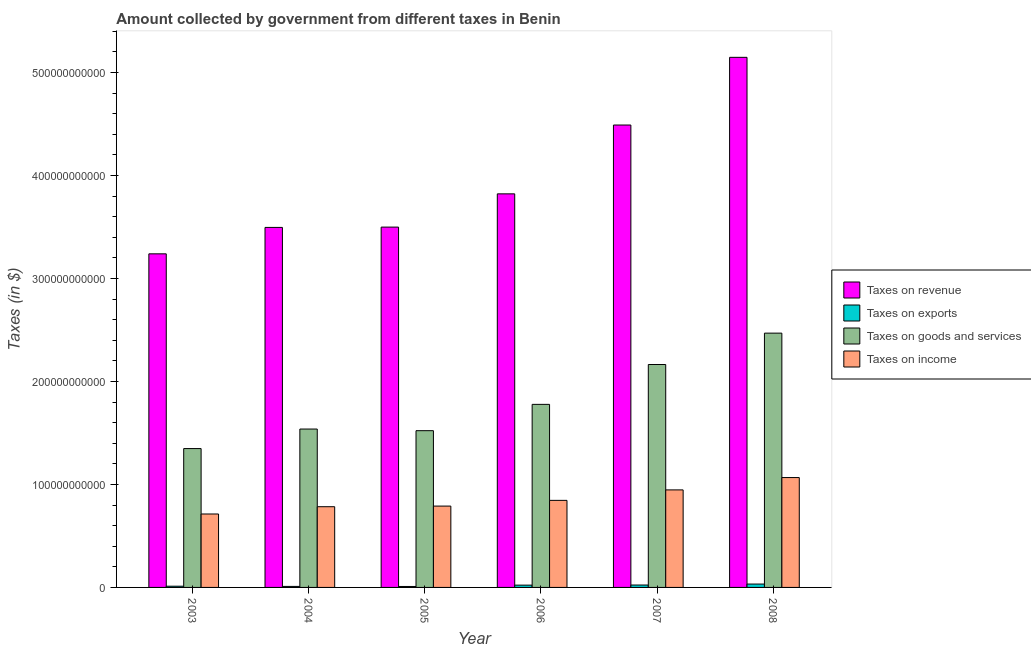Are the number of bars per tick equal to the number of legend labels?
Offer a terse response. Yes. Are the number of bars on each tick of the X-axis equal?
Keep it short and to the point. Yes. In how many cases, is the number of bars for a given year not equal to the number of legend labels?
Offer a very short reply. 0. What is the amount collected as tax on goods in 2008?
Your answer should be very brief. 2.47e+11. Across all years, what is the maximum amount collected as tax on revenue?
Provide a short and direct response. 5.15e+11. Across all years, what is the minimum amount collected as tax on goods?
Offer a very short reply. 1.35e+11. In which year was the amount collected as tax on revenue maximum?
Provide a succinct answer. 2008. In which year was the amount collected as tax on exports minimum?
Offer a terse response. 2005. What is the total amount collected as tax on revenue in the graph?
Give a very brief answer. 2.37e+12. What is the difference between the amount collected as tax on exports in 2007 and that in 2008?
Your answer should be compact. -9.29e+08. What is the difference between the amount collected as tax on revenue in 2005 and the amount collected as tax on goods in 2004?
Offer a terse response. 3.07e+08. What is the average amount collected as tax on goods per year?
Your answer should be very brief. 1.80e+11. In the year 2005, what is the difference between the amount collected as tax on exports and amount collected as tax on revenue?
Offer a terse response. 0. What is the ratio of the amount collected as tax on income in 2005 to that in 2008?
Your response must be concise. 0.74. Is the amount collected as tax on income in 2005 less than that in 2007?
Provide a short and direct response. Yes. Is the difference between the amount collected as tax on exports in 2003 and 2005 greater than the difference between the amount collected as tax on goods in 2003 and 2005?
Give a very brief answer. No. What is the difference between the highest and the second highest amount collected as tax on revenue?
Make the answer very short. 6.57e+1. What is the difference between the highest and the lowest amount collected as tax on goods?
Give a very brief answer. 1.12e+11. Is the sum of the amount collected as tax on revenue in 2004 and 2006 greater than the maximum amount collected as tax on goods across all years?
Your response must be concise. Yes. What does the 2nd bar from the left in 2005 represents?
Your answer should be very brief. Taxes on exports. What does the 1st bar from the right in 2008 represents?
Give a very brief answer. Taxes on income. Are all the bars in the graph horizontal?
Make the answer very short. No. How many years are there in the graph?
Make the answer very short. 6. What is the difference between two consecutive major ticks on the Y-axis?
Make the answer very short. 1.00e+11. Are the values on the major ticks of Y-axis written in scientific E-notation?
Provide a short and direct response. No. Does the graph contain any zero values?
Your answer should be very brief. No. Does the graph contain grids?
Give a very brief answer. No. Where does the legend appear in the graph?
Offer a very short reply. Center right. How many legend labels are there?
Keep it short and to the point. 4. How are the legend labels stacked?
Keep it short and to the point. Vertical. What is the title of the graph?
Offer a terse response. Amount collected by government from different taxes in Benin. Does "PFC gas" appear as one of the legend labels in the graph?
Offer a terse response. No. What is the label or title of the X-axis?
Make the answer very short. Year. What is the label or title of the Y-axis?
Keep it short and to the point. Taxes (in $). What is the Taxes (in $) of Taxes on revenue in 2003?
Your answer should be compact. 3.24e+11. What is the Taxes (in $) of Taxes on exports in 2003?
Your answer should be compact. 1.17e+09. What is the Taxes (in $) of Taxes on goods and services in 2003?
Give a very brief answer. 1.35e+11. What is the Taxes (in $) in Taxes on income in 2003?
Your answer should be very brief. 7.13e+1. What is the Taxes (in $) in Taxes on revenue in 2004?
Your answer should be very brief. 3.50e+11. What is the Taxes (in $) of Taxes on exports in 2004?
Ensure brevity in your answer.  9.76e+08. What is the Taxes (in $) in Taxes on goods and services in 2004?
Offer a terse response. 1.54e+11. What is the Taxes (in $) in Taxes on income in 2004?
Make the answer very short. 7.84e+1. What is the Taxes (in $) of Taxes on revenue in 2005?
Keep it short and to the point. 3.50e+11. What is the Taxes (in $) of Taxes on exports in 2005?
Provide a short and direct response. 9.19e+08. What is the Taxes (in $) in Taxes on goods and services in 2005?
Offer a terse response. 1.52e+11. What is the Taxes (in $) in Taxes on income in 2005?
Offer a very short reply. 7.90e+1. What is the Taxes (in $) in Taxes on revenue in 2006?
Keep it short and to the point. 3.82e+11. What is the Taxes (in $) in Taxes on exports in 2006?
Your response must be concise. 2.23e+09. What is the Taxes (in $) of Taxes on goods and services in 2006?
Ensure brevity in your answer.  1.78e+11. What is the Taxes (in $) in Taxes on income in 2006?
Provide a succinct answer. 8.45e+1. What is the Taxes (in $) in Taxes on revenue in 2007?
Your response must be concise. 4.49e+11. What is the Taxes (in $) of Taxes on exports in 2007?
Offer a terse response. 2.34e+09. What is the Taxes (in $) of Taxes on goods and services in 2007?
Your response must be concise. 2.16e+11. What is the Taxes (in $) in Taxes on income in 2007?
Keep it short and to the point. 9.47e+1. What is the Taxes (in $) of Taxes on revenue in 2008?
Provide a succinct answer. 5.15e+11. What is the Taxes (in $) in Taxes on exports in 2008?
Ensure brevity in your answer.  3.27e+09. What is the Taxes (in $) of Taxes on goods and services in 2008?
Make the answer very short. 2.47e+11. What is the Taxes (in $) of Taxes on income in 2008?
Provide a short and direct response. 1.07e+11. Across all years, what is the maximum Taxes (in $) in Taxes on revenue?
Provide a succinct answer. 5.15e+11. Across all years, what is the maximum Taxes (in $) in Taxes on exports?
Keep it short and to the point. 3.27e+09. Across all years, what is the maximum Taxes (in $) in Taxes on goods and services?
Keep it short and to the point. 2.47e+11. Across all years, what is the maximum Taxes (in $) in Taxes on income?
Give a very brief answer. 1.07e+11. Across all years, what is the minimum Taxes (in $) of Taxes on revenue?
Offer a very short reply. 3.24e+11. Across all years, what is the minimum Taxes (in $) in Taxes on exports?
Make the answer very short. 9.19e+08. Across all years, what is the minimum Taxes (in $) in Taxes on goods and services?
Make the answer very short. 1.35e+11. Across all years, what is the minimum Taxes (in $) of Taxes on income?
Offer a very short reply. 7.13e+1. What is the total Taxes (in $) in Taxes on revenue in the graph?
Offer a terse response. 2.37e+12. What is the total Taxes (in $) of Taxes on exports in the graph?
Provide a succinct answer. 1.09e+1. What is the total Taxes (in $) in Taxes on goods and services in the graph?
Provide a short and direct response. 1.08e+12. What is the total Taxes (in $) of Taxes on income in the graph?
Provide a succinct answer. 5.15e+11. What is the difference between the Taxes (in $) in Taxes on revenue in 2003 and that in 2004?
Give a very brief answer. -2.57e+1. What is the difference between the Taxes (in $) of Taxes on exports in 2003 and that in 2004?
Make the answer very short. 1.98e+08. What is the difference between the Taxes (in $) in Taxes on goods and services in 2003 and that in 2004?
Offer a very short reply. -1.90e+1. What is the difference between the Taxes (in $) in Taxes on income in 2003 and that in 2004?
Provide a short and direct response. -7.07e+09. What is the difference between the Taxes (in $) in Taxes on revenue in 2003 and that in 2005?
Make the answer very short. -2.60e+1. What is the difference between the Taxes (in $) in Taxes on exports in 2003 and that in 2005?
Provide a short and direct response. 2.54e+08. What is the difference between the Taxes (in $) in Taxes on goods and services in 2003 and that in 2005?
Make the answer very short. -1.74e+1. What is the difference between the Taxes (in $) of Taxes on income in 2003 and that in 2005?
Provide a succinct answer. -7.68e+09. What is the difference between the Taxes (in $) in Taxes on revenue in 2003 and that in 2006?
Ensure brevity in your answer.  -5.82e+1. What is the difference between the Taxes (in $) in Taxes on exports in 2003 and that in 2006?
Provide a succinct answer. -1.06e+09. What is the difference between the Taxes (in $) in Taxes on goods and services in 2003 and that in 2006?
Make the answer very short. -4.29e+1. What is the difference between the Taxes (in $) of Taxes on income in 2003 and that in 2006?
Provide a short and direct response. -1.32e+1. What is the difference between the Taxes (in $) of Taxes on revenue in 2003 and that in 2007?
Your answer should be compact. -1.25e+11. What is the difference between the Taxes (in $) of Taxes on exports in 2003 and that in 2007?
Offer a terse response. -1.17e+09. What is the difference between the Taxes (in $) of Taxes on goods and services in 2003 and that in 2007?
Your answer should be compact. -8.16e+1. What is the difference between the Taxes (in $) in Taxes on income in 2003 and that in 2007?
Your answer should be compact. -2.34e+1. What is the difference between the Taxes (in $) of Taxes on revenue in 2003 and that in 2008?
Your answer should be compact. -1.91e+11. What is the difference between the Taxes (in $) of Taxes on exports in 2003 and that in 2008?
Your answer should be very brief. -2.09e+09. What is the difference between the Taxes (in $) of Taxes on goods and services in 2003 and that in 2008?
Offer a terse response. -1.12e+11. What is the difference between the Taxes (in $) in Taxes on income in 2003 and that in 2008?
Provide a short and direct response. -3.54e+1. What is the difference between the Taxes (in $) of Taxes on revenue in 2004 and that in 2005?
Ensure brevity in your answer.  -3.07e+08. What is the difference between the Taxes (in $) of Taxes on exports in 2004 and that in 2005?
Provide a succinct answer. 5.63e+07. What is the difference between the Taxes (in $) of Taxes on goods and services in 2004 and that in 2005?
Your answer should be very brief. 1.60e+09. What is the difference between the Taxes (in $) in Taxes on income in 2004 and that in 2005?
Keep it short and to the point. -6.13e+08. What is the difference between the Taxes (in $) of Taxes on revenue in 2004 and that in 2006?
Offer a very short reply. -3.26e+1. What is the difference between the Taxes (in $) in Taxes on exports in 2004 and that in 2006?
Provide a short and direct response. -1.25e+09. What is the difference between the Taxes (in $) of Taxes on goods and services in 2004 and that in 2006?
Provide a succinct answer. -2.39e+1. What is the difference between the Taxes (in $) of Taxes on income in 2004 and that in 2006?
Make the answer very short. -6.16e+09. What is the difference between the Taxes (in $) in Taxes on revenue in 2004 and that in 2007?
Your answer should be compact. -9.94e+1. What is the difference between the Taxes (in $) in Taxes on exports in 2004 and that in 2007?
Your answer should be compact. -1.36e+09. What is the difference between the Taxes (in $) of Taxes on goods and services in 2004 and that in 2007?
Your answer should be very brief. -6.27e+1. What is the difference between the Taxes (in $) of Taxes on income in 2004 and that in 2007?
Keep it short and to the point. -1.63e+1. What is the difference between the Taxes (in $) of Taxes on revenue in 2004 and that in 2008?
Make the answer very short. -1.65e+11. What is the difference between the Taxes (in $) of Taxes on exports in 2004 and that in 2008?
Your answer should be very brief. -2.29e+09. What is the difference between the Taxes (in $) of Taxes on goods and services in 2004 and that in 2008?
Keep it short and to the point. -9.31e+1. What is the difference between the Taxes (in $) of Taxes on income in 2004 and that in 2008?
Offer a terse response. -2.83e+1. What is the difference between the Taxes (in $) in Taxes on revenue in 2005 and that in 2006?
Your answer should be compact. -3.23e+1. What is the difference between the Taxes (in $) in Taxes on exports in 2005 and that in 2006?
Give a very brief answer. -1.31e+09. What is the difference between the Taxes (in $) in Taxes on goods and services in 2005 and that in 2006?
Your answer should be compact. -2.55e+1. What is the difference between the Taxes (in $) of Taxes on income in 2005 and that in 2006?
Give a very brief answer. -5.54e+09. What is the difference between the Taxes (in $) in Taxes on revenue in 2005 and that in 2007?
Your response must be concise. -9.91e+1. What is the difference between the Taxes (in $) of Taxes on exports in 2005 and that in 2007?
Your answer should be very brief. -1.42e+09. What is the difference between the Taxes (in $) in Taxes on goods and services in 2005 and that in 2007?
Provide a succinct answer. -6.43e+1. What is the difference between the Taxes (in $) of Taxes on income in 2005 and that in 2007?
Provide a succinct answer. -1.57e+1. What is the difference between the Taxes (in $) of Taxes on revenue in 2005 and that in 2008?
Ensure brevity in your answer.  -1.65e+11. What is the difference between the Taxes (in $) in Taxes on exports in 2005 and that in 2008?
Keep it short and to the point. -2.35e+09. What is the difference between the Taxes (in $) in Taxes on goods and services in 2005 and that in 2008?
Give a very brief answer. -9.47e+1. What is the difference between the Taxes (in $) in Taxes on income in 2005 and that in 2008?
Offer a terse response. -2.77e+1. What is the difference between the Taxes (in $) in Taxes on revenue in 2006 and that in 2007?
Ensure brevity in your answer.  -6.68e+1. What is the difference between the Taxes (in $) of Taxes on exports in 2006 and that in 2007?
Make the answer very short. -1.09e+08. What is the difference between the Taxes (in $) of Taxes on goods and services in 2006 and that in 2007?
Your answer should be compact. -3.87e+1. What is the difference between the Taxes (in $) of Taxes on income in 2006 and that in 2007?
Your response must be concise. -1.02e+1. What is the difference between the Taxes (in $) in Taxes on revenue in 2006 and that in 2008?
Offer a terse response. -1.33e+11. What is the difference between the Taxes (in $) in Taxes on exports in 2006 and that in 2008?
Your answer should be compact. -1.04e+09. What is the difference between the Taxes (in $) in Taxes on goods and services in 2006 and that in 2008?
Your answer should be compact. -6.92e+1. What is the difference between the Taxes (in $) of Taxes on income in 2006 and that in 2008?
Provide a short and direct response. -2.22e+1. What is the difference between the Taxes (in $) in Taxes on revenue in 2007 and that in 2008?
Provide a succinct answer. -6.57e+1. What is the difference between the Taxes (in $) of Taxes on exports in 2007 and that in 2008?
Ensure brevity in your answer.  -9.29e+08. What is the difference between the Taxes (in $) of Taxes on goods and services in 2007 and that in 2008?
Your response must be concise. -3.05e+1. What is the difference between the Taxes (in $) of Taxes on income in 2007 and that in 2008?
Make the answer very short. -1.20e+1. What is the difference between the Taxes (in $) in Taxes on revenue in 2003 and the Taxes (in $) in Taxes on exports in 2004?
Your answer should be very brief. 3.23e+11. What is the difference between the Taxes (in $) in Taxes on revenue in 2003 and the Taxes (in $) in Taxes on goods and services in 2004?
Give a very brief answer. 1.70e+11. What is the difference between the Taxes (in $) of Taxes on revenue in 2003 and the Taxes (in $) of Taxes on income in 2004?
Your answer should be compact. 2.46e+11. What is the difference between the Taxes (in $) of Taxes on exports in 2003 and the Taxes (in $) of Taxes on goods and services in 2004?
Make the answer very short. -1.53e+11. What is the difference between the Taxes (in $) in Taxes on exports in 2003 and the Taxes (in $) in Taxes on income in 2004?
Provide a short and direct response. -7.72e+1. What is the difference between the Taxes (in $) in Taxes on goods and services in 2003 and the Taxes (in $) in Taxes on income in 2004?
Offer a very short reply. 5.65e+1. What is the difference between the Taxes (in $) of Taxes on revenue in 2003 and the Taxes (in $) of Taxes on exports in 2005?
Keep it short and to the point. 3.23e+11. What is the difference between the Taxes (in $) in Taxes on revenue in 2003 and the Taxes (in $) in Taxes on goods and services in 2005?
Your response must be concise. 1.72e+11. What is the difference between the Taxes (in $) of Taxes on revenue in 2003 and the Taxes (in $) of Taxes on income in 2005?
Ensure brevity in your answer.  2.45e+11. What is the difference between the Taxes (in $) in Taxes on exports in 2003 and the Taxes (in $) in Taxes on goods and services in 2005?
Provide a succinct answer. -1.51e+11. What is the difference between the Taxes (in $) in Taxes on exports in 2003 and the Taxes (in $) in Taxes on income in 2005?
Keep it short and to the point. -7.78e+1. What is the difference between the Taxes (in $) of Taxes on goods and services in 2003 and the Taxes (in $) of Taxes on income in 2005?
Your answer should be very brief. 5.58e+1. What is the difference between the Taxes (in $) of Taxes on revenue in 2003 and the Taxes (in $) of Taxes on exports in 2006?
Your response must be concise. 3.22e+11. What is the difference between the Taxes (in $) of Taxes on revenue in 2003 and the Taxes (in $) of Taxes on goods and services in 2006?
Give a very brief answer. 1.46e+11. What is the difference between the Taxes (in $) of Taxes on revenue in 2003 and the Taxes (in $) of Taxes on income in 2006?
Ensure brevity in your answer.  2.39e+11. What is the difference between the Taxes (in $) in Taxes on exports in 2003 and the Taxes (in $) in Taxes on goods and services in 2006?
Your response must be concise. -1.77e+11. What is the difference between the Taxes (in $) in Taxes on exports in 2003 and the Taxes (in $) in Taxes on income in 2006?
Your answer should be compact. -8.34e+1. What is the difference between the Taxes (in $) in Taxes on goods and services in 2003 and the Taxes (in $) in Taxes on income in 2006?
Offer a very short reply. 5.03e+1. What is the difference between the Taxes (in $) in Taxes on revenue in 2003 and the Taxes (in $) in Taxes on exports in 2007?
Offer a terse response. 3.22e+11. What is the difference between the Taxes (in $) of Taxes on revenue in 2003 and the Taxes (in $) of Taxes on goods and services in 2007?
Provide a succinct answer. 1.07e+11. What is the difference between the Taxes (in $) in Taxes on revenue in 2003 and the Taxes (in $) in Taxes on income in 2007?
Give a very brief answer. 2.29e+11. What is the difference between the Taxes (in $) in Taxes on exports in 2003 and the Taxes (in $) in Taxes on goods and services in 2007?
Your answer should be compact. -2.15e+11. What is the difference between the Taxes (in $) in Taxes on exports in 2003 and the Taxes (in $) in Taxes on income in 2007?
Your answer should be compact. -9.35e+1. What is the difference between the Taxes (in $) in Taxes on goods and services in 2003 and the Taxes (in $) in Taxes on income in 2007?
Your answer should be compact. 4.01e+1. What is the difference between the Taxes (in $) in Taxes on revenue in 2003 and the Taxes (in $) in Taxes on exports in 2008?
Your answer should be very brief. 3.21e+11. What is the difference between the Taxes (in $) of Taxes on revenue in 2003 and the Taxes (in $) of Taxes on goods and services in 2008?
Keep it short and to the point. 7.70e+1. What is the difference between the Taxes (in $) of Taxes on revenue in 2003 and the Taxes (in $) of Taxes on income in 2008?
Your answer should be very brief. 2.17e+11. What is the difference between the Taxes (in $) of Taxes on exports in 2003 and the Taxes (in $) of Taxes on goods and services in 2008?
Provide a short and direct response. -2.46e+11. What is the difference between the Taxes (in $) in Taxes on exports in 2003 and the Taxes (in $) in Taxes on income in 2008?
Offer a terse response. -1.06e+11. What is the difference between the Taxes (in $) in Taxes on goods and services in 2003 and the Taxes (in $) in Taxes on income in 2008?
Offer a terse response. 2.81e+1. What is the difference between the Taxes (in $) in Taxes on revenue in 2004 and the Taxes (in $) in Taxes on exports in 2005?
Keep it short and to the point. 3.49e+11. What is the difference between the Taxes (in $) of Taxes on revenue in 2004 and the Taxes (in $) of Taxes on goods and services in 2005?
Your response must be concise. 1.97e+11. What is the difference between the Taxes (in $) of Taxes on revenue in 2004 and the Taxes (in $) of Taxes on income in 2005?
Your answer should be very brief. 2.71e+11. What is the difference between the Taxes (in $) in Taxes on exports in 2004 and the Taxes (in $) in Taxes on goods and services in 2005?
Keep it short and to the point. -1.51e+11. What is the difference between the Taxes (in $) of Taxes on exports in 2004 and the Taxes (in $) of Taxes on income in 2005?
Provide a short and direct response. -7.80e+1. What is the difference between the Taxes (in $) of Taxes on goods and services in 2004 and the Taxes (in $) of Taxes on income in 2005?
Keep it short and to the point. 7.48e+1. What is the difference between the Taxes (in $) of Taxes on revenue in 2004 and the Taxes (in $) of Taxes on exports in 2006?
Ensure brevity in your answer.  3.47e+11. What is the difference between the Taxes (in $) of Taxes on revenue in 2004 and the Taxes (in $) of Taxes on goods and services in 2006?
Your answer should be compact. 1.72e+11. What is the difference between the Taxes (in $) of Taxes on revenue in 2004 and the Taxes (in $) of Taxes on income in 2006?
Provide a succinct answer. 2.65e+11. What is the difference between the Taxes (in $) of Taxes on exports in 2004 and the Taxes (in $) of Taxes on goods and services in 2006?
Ensure brevity in your answer.  -1.77e+11. What is the difference between the Taxes (in $) of Taxes on exports in 2004 and the Taxes (in $) of Taxes on income in 2006?
Your answer should be very brief. -8.36e+1. What is the difference between the Taxes (in $) in Taxes on goods and services in 2004 and the Taxes (in $) in Taxes on income in 2006?
Offer a very short reply. 6.93e+1. What is the difference between the Taxes (in $) in Taxes on revenue in 2004 and the Taxes (in $) in Taxes on exports in 2007?
Offer a very short reply. 3.47e+11. What is the difference between the Taxes (in $) in Taxes on revenue in 2004 and the Taxes (in $) in Taxes on goods and services in 2007?
Offer a very short reply. 1.33e+11. What is the difference between the Taxes (in $) of Taxes on revenue in 2004 and the Taxes (in $) of Taxes on income in 2007?
Your answer should be compact. 2.55e+11. What is the difference between the Taxes (in $) of Taxes on exports in 2004 and the Taxes (in $) of Taxes on goods and services in 2007?
Offer a very short reply. -2.15e+11. What is the difference between the Taxes (in $) of Taxes on exports in 2004 and the Taxes (in $) of Taxes on income in 2007?
Your response must be concise. -9.37e+1. What is the difference between the Taxes (in $) of Taxes on goods and services in 2004 and the Taxes (in $) of Taxes on income in 2007?
Ensure brevity in your answer.  5.91e+1. What is the difference between the Taxes (in $) of Taxes on revenue in 2004 and the Taxes (in $) of Taxes on exports in 2008?
Make the answer very short. 3.46e+11. What is the difference between the Taxes (in $) of Taxes on revenue in 2004 and the Taxes (in $) of Taxes on goods and services in 2008?
Offer a very short reply. 1.03e+11. What is the difference between the Taxes (in $) of Taxes on revenue in 2004 and the Taxes (in $) of Taxes on income in 2008?
Give a very brief answer. 2.43e+11. What is the difference between the Taxes (in $) in Taxes on exports in 2004 and the Taxes (in $) in Taxes on goods and services in 2008?
Make the answer very short. -2.46e+11. What is the difference between the Taxes (in $) of Taxes on exports in 2004 and the Taxes (in $) of Taxes on income in 2008?
Provide a short and direct response. -1.06e+11. What is the difference between the Taxes (in $) in Taxes on goods and services in 2004 and the Taxes (in $) in Taxes on income in 2008?
Make the answer very short. 4.71e+1. What is the difference between the Taxes (in $) in Taxes on revenue in 2005 and the Taxes (in $) in Taxes on exports in 2006?
Your answer should be very brief. 3.48e+11. What is the difference between the Taxes (in $) of Taxes on revenue in 2005 and the Taxes (in $) of Taxes on goods and services in 2006?
Your answer should be compact. 1.72e+11. What is the difference between the Taxes (in $) of Taxes on revenue in 2005 and the Taxes (in $) of Taxes on income in 2006?
Give a very brief answer. 2.65e+11. What is the difference between the Taxes (in $) in Taxes on exports in 2005 and the Taxes (in $) in Taxes on goods and services in 2006?
Provide a succinct answer. -1.77e+11. What is the difference between the Taxes (in $) of Taxes on exports in 2005 and the Taxes (in $) of Taxes on income in 2006?
Provide a short and direct response. -8.36e+1. What is the difference between the Taxes (in $) in Taxes on goods and services in 2005 and the Taxes (in $) in Taxes on income in 2006?
Your answer should be compact. 6.77e+1. What is the difference between the Taxes (in $) in Taxes on revenue in 2005 and the Taxes (in $) in Taxes on exports in 2007?
Your answer should be very brief. 3.48e+11. What is the difference between the Taxes (in $) in Taxes on revenue in 2005 and the Taxes (in $) in Taxes on goods and services in 2007?
Provide a short and direct response. 1.33e+11. What is the difference between the Taxes (in $) in Taxes on revenue in 2005 and the Taxes (in $) in Taxes on income in 2007?
Your answer should be very brief. 2.55e+11. What is the difference between the Taxes (in $) of Taxes on exports in 2005 and the Taxes (in $) of Taxes on goods and services in 2007?
Give a very brief answer. -2.16e+11. What is the difference between the Taxes (in $) in Taxes on exports in 2005 and the Taxes (in $) in Taxes on income in 2007?
Your response must be concise. -9.38e+1. What is the difference between the Taxes (in $) of Taxes on goods and services in 2005 and the Taxes (in $) of Taxes on income in 2007?
Provide a short and direct response. 5.75e+1. What is the difference between the Taxes (in $) of Taxes on revenue in 2005 and the Taxes (in $) of Taxes on exports in 2008?
Keep it short and to the point. 3.47e+11. What is the difference between the Taxes (in $) of Taxes on revenue in 2005 and the Taxes (in $) of Taxes on goods and services in 2008?
Give a very brief answer. 1.03e+11. What is the difference between the Taxes (in $) of Taxes on revenue in 2005 and the Taxes (in $) of Taxes on income in 2008?
Ensure brevity in your answer.  2.43e+11. What is the difference between the Taxes (in $) of Taxes on exports in 2005 and the Taxes (in $) of Taxes on goods and services in 2008?
Provide a short and direct response. -2.46e+11. What is the difference between the Taxes (in $) in Taxes on exports in 2005 and the Taxes (in $) in Taxes on income in 2008?
Your answer should be compact. -1.06e+11. What is the difference between the Taxes (in $) of Taxes on goods and services in 2005 and the Taxes (in $) of Taxes on income in 2008?
Your answer should be compact. 4.55e+1. What is the difference between the Taxes (in $) of Taxes on revenue in 2006 and the Taxes (in $) of Taxes on exports in 2007?
Keep it short and to the point. 3.80e+11. What is the difference between the Taxes (in $) of Taxes on revenue in 2006 and the Taxes (in $) of Taxes on goods and services in 2007?
Make the answer very short. 1.66e+11. What is the difference between the Taxes (in $) of Taxes on revenue in 2006 and the Taxes (in $) of Taxes on income in 2007?
Provide a succinct answer. 2.87e+11. What is the difference between the Taxes (in $) of Taxes on exports in 2006 and the Taxes (in $) of Taxes on goods and services in 2007?
Provide a succinct answer. -2.14e+11. What is the difference between the Taxes (in $) of Taxes on exports in 2006 and the Taxes (in $) of Taxes on income in 2007?
Keep it short and to the point. -9.25e+1. What is the difference between the Taxes (in $) in Taxes on goods and services in 2006 and the Taxes (in $) in Taxes on income in 2007?
Your answer should be compact. 8.31e+1. What is the difference between the Taxes (in $) in Taxes on revenue in 2006 and the Taxes (in $) in Taxes on exports in 2008?
Make the answer very short. 3.79e+11. What is the difference between the Taxes (in $) of Taxes on revenue in 2006 and the Taxes (in $) of Taxes on goods and services in 2008?
Your answer should be very brief. 1.35e+11. What is the difference between the Taxes (in $) in Taxes on revenue in 2006 and the Taxes (in $) in Taxes on income in 2008?
Offer a terse response. 2.75e+11. What is the difference between the Taxes (in $) in Taxes on exports in 2006 and the Taxes (in $) in Taxes on goods and services in 2008?
Make the answer very short. -2.45e+11. What is the difference between the Taxes (in $) of Taxes on exports in 2006 and the Taxes (in $) of Taxes on income in 2008?
Provide a succinct answer. -1.04e+11. What is the difference between the Taxes (in $) in Taxes on goods and services in 2006 and the Taxes (in $) in Taxes on income in 2008?
Keep it short and to the point. 7.11e+1. What is the difference between the Taxes (in $) in Taxes on revenue in 2007 and the Taxes (in $) in Taxes on exports in 2008?
Provide a short and direct response. 4.46e+11. What is the difference between the Taxes (in $) of Taxes on revenue in 2007 and the Taxes (in $) of Taxes on goods and services in 2008?
Give a very brief answer. 2.02e+11. What is the difference between the Taxes (in $) in Taxes on revenue in 2007 and the Taxes (in $) in Taxes on income in 2008?
Your response must be concise. 3.42e+11. What is the difference between the Taxes (in $) of Taxes on exports in 2007 and the Taxes (in $) of Taxes on goods and services in 2008?
Your answer should be compact. -2.45e+11. What is the difference between the Taxes (in $) in Taxes on exports in 2007 and the Taxes (in $) in Taxes on income in 2008?
Offer a terse response. -1.04e+11. What is the difference between the Taxes (in $) of Taxes on goods and services in 2007 and the Taxes (in $) of Taxes on income in 2008?
Your answer should be compact. 1.10e+11. What is the average Taxes (in $) of Taxes on revenue per year?
Offer a very short reply. 3.95e+11. What is the average Taxes (in $) of Taxes on exports per year?
Make the answer very short. 1.82e+09. What is the average Taxes (in $) of Taxes on goods and services per year?
Offer a terse response. 1.80e+11. What is the average Taxes (in $) in Taxes on income per year?
Your answer should be compact. 8.58e+1. In the year 2003, what is the difference between the Taxes (in $) of Taxes on revenue and Taxes (in $) of Taxes on exports?
Your answer should be compact. 3.23e+11. In the year 2003, what is the difference between the Taxes (in $) in Taxes on revenue and Taxes (in $) in Taxes on goods and services?
Keep it short and to the point. 1.89e+11. In the year 2003, what is the difference between the Taxes (in $) in Taxes on revenue and Taxes (in $) in Taxes on income?
Offer a very short reply. 2.53e+11. In the year 2003, what is the difference between the Taxes (in $) in Taxes on exports and Taxes (in $) in Taxes on goods and services?
Your answer should be compact. -1.34e+11. In the year 2003, what is the difference between the Taxes (in $) in Taxes on exports and Taxes (in $) in Taxes on income?
Keep it short and to the point. -7.01e+1. In the year 2003, what is the difference between the Taxes (in $) of Taxes on goods and services and Taxes (in $) of Taxes on income?
Your response must be concise. 6.35e+1. In the year 2004, what is the difference between the Taxes (in $) of Taxes on revenue and Taxes (in $) of Taxes on exports?
Your answer should be compact. 3.49e+11. In the year 2004, what is the difference between the Taxes (in $) in Taxes on revenue and Taxes (in $) in Taxes on goods and services?
Offer a very short reply. 1.96e+11. In the year 2004, what is the difference between the Taxes (in $) of Taxes on revenue and Taxes (in $) of Taxes on income?
Provide a succinct answer. 2.71e+11. In the year 2004, what is the difference between the Taxes (in $) of Taxes on exports and Taxes (in $) of Taxes on goods and services?
Your answer should be compact. -1.53e+11. In the year 2004, what is the difference between the Taxes (in $) in Taxes on exports and Taxes (in $) in Taxes on income?
Your answer should be compact. -7.74e+1. In the year 2004, what is the difference between the Taxes (in $) of Taxes on goods and services and Taxes (in $) of Taxes on income?
Give a very brief answer. 7.54e+1. In the year 2005, what is the difference between the Taxes (in $) of Taxes on revenue and Taxes (in $) of Taxes on exports?
Provide a short and direct response. 3.49e+11. In the year 2005, what is the difference between the Taxes (in $) of Taxes on revenue and Taxes (in $) of Taxes on goods and services?
Make the answer very short. 1.98e+11. In the year 2005, what is the difference between the Taxes (in $) in Taxes on revenue and Taxes (in $) in Taxes on income?
Give a very brief answer. 2.71e+11. In the year 2005, what is the difference between the Taxes (in $) in Taxes on exports and Taxes (in $) in Taxes on goods and services?
Provide a short and direct response. -1.51e+11. In the year 2005, what is the difference between the Taxes (in $) in Taxes on exports and Taxes (in $) in Taxes on income?
Provide a short and direct response. -7.81e+1. In the year 2005, what is the difference between the Taxes (in $) of Taxes on goods and services and Taxes (in $) of Taxes on income?
Ensure brevity in your answer.  7.32e+1. In the year 2006, what is the difference between the Taxes (in $) in Taxes on revenue and Taxes (in $) in Taxes on exports?
Your answer should be compact. 3.80e+11. In the year 2006, what is the difference between the Taxes (in $) in Taxes on revenue and Taxes (in $) in Taxes on goods and services?
Your answer should be very brief. 2.04e+11. In the year 2006, what is the difference between the Taxes (in $) in Taxes on revenue and Taxes (in $) in Taxes on income?
Your answer should be very brief. 2.98e+11. In the year 2006, what is the difference between the Taxes (in $) in Taxes on exports and Taxes (in $) in Taxes on goods and services?
Your response must be concise. -1.76e+11. In the year 2006, what is the difference between the Taxes (in $) in Taxes on exports and Taxes (in $) in Taxes on income?
Offer a very short reply. -8.23e+1. In the year 2006, what is the difference between the Taxes (in $) in Taxes on goods and services and Taxes (in $) in Taxes on income?
Keep it short and to the point. 9.32e+1. In the year 2007, what is the difference between the Taxes (in $) in Taxes on revenue and Taxes (in $) in Taxes on exports?
Your answer should be very brief. 4.47e+11. In the year 2007, what is the difference between the Taxes (in $) in Taxes on revenue and Taxes (in $) in Taxes on goods and services?
Offer a terse response. 2.33e+11. In the year 2007, what is the difference between the Taxes (in $) of Taxes on revenue and Taxes (in $) of Taxes on income?
Your response must be concise. 3.54e+11. In the year 2007, what is the difference between the Taxes (in $) of Taxes on exports and Taxes (in $) of Taxes on goods and services?
Ensure brevity in your answer.  -2.14e+11. In the year 2007, what is the difference between the Taxes (in $) in Taxes on exports and Taxes (in $) in Taxes on income?
Keep it short and to the point. -9.24e+1. In the year 2007, what is the difference between the Taxes (in $) of Taxes on goods and services and Taxes (in $) of Taxes on income?
Offer a terse response. 1.22e+11. In the year 2008, what is the difference between the Taxes (in $) in Taxes on revenue and Taxes (in $) in Taxes on exports?
Your answer should be compact. 5.11e+11. In the year 2008, what is the difference between the Taxes (in $) of Taxes on revenue and Taxes (in $) of Taxes on goods and services?
Give a very brief answer. 2.68e+11. In the year 2008, what is the difference between the Taxes (in $) in Taxes on revenue and Taxes (in $) in Taxes on income?
Offer a very short reply. 4.08e+11. In the year 2008, what is the difference between the Taxes (in $) of Taxes on exports and Taxes (in $) of Taxes on goods and services?
Your answer should be very brief. -2.44e+11. In the year 2008, what is the difference between the Taxes (in $) in Taxes on exports and Taxes (in $) in Taxes on income?
Ensure brevity in your answer.  -1.03e+11. In the year 2008, what is the difference between the Taxes (in $) of Taxes on goods and services and Taxes (in $) of Taxes on income?
Offer a terse response. 1.40e+11. What is the ratio of the Taxes (in $) in Taxes on revenue in 2003 to that in 2004?
Offer a very short reply. 0.93. What is the ratio of the Taxes (in $) of Taxes on exports in 2003 to that in 2004?
Give a very brief answer. 1.2. What is the ratio of the Taxes (in $) of Taxes on goods and services in 2003 to that in 2004?
Offer a terse response. 0.88. What is the ratio of the Taxes (in $) of Taxes on income in 2003 to that in 2004?
Provide a short and direct response. 0.91. What is the ratio of the Taxes (in $) in Taxes on revenue in 2003 to that in 2005?
Your answer should be very brief. 0.93. What is the ratio of the Taxes (in $) in Taxes on exports in 2003 to that in 2005?
Your response must be concise. 1.28. What is the ratio of the Taxes (in $) of Taxes on goods and services in 2003 to that in 2005?
Ensure brevity in your answer.  0.89. What is the ratio of the Taxes (in $) in Taxes on income in 2003 to that in 2005?
Your answer should be very brief. 0.9. What is the ratio of the Taxes (in $) of Taxes on revenue in 2003 to that in 2006?
Offer a terse response. 0.85. What is the ratio of the Taxes (in $) in Taxes on exports in 2003 to that in 2006?
Provide a short and direct response. 0.53. What is the ratio of the Taxes (in $) in Taxes on goods and services in 2003 to that in 2006?
Offer a very short reply. 0.76. What is the ratio of the Taxes (in $) of Taxes on income in 2003 to that in 2006?
Make the answer very short. 0.84. What is the ratio of the Taxes (in $) of Taxes on revenue in 2003 to that in 2007?
Ensure brevity in your answer.  0.72. What is the ratio of the Taxes (in $) in Taxes on exports in 2003 to that in 2007?
Make the answer very short. 0.5. What is the ratio of the Taxes (in $) in Taxes on goods and services in 2003 to that in 2007?
Keep it short and to the point. 0.62. What is the ratio of the Taxes (in $) in Taxes on income in 2003 to that in 2007?
Your answer should be very brief. 0.75. What is the ratio of the Taxes (in $) in Taxes on revenue in 2003 to that in 2008?
Offer a very short reply. 0.63. What is the ratio of the Taxes (in $) in Taxes on exports in 2003 to that in 2008?
Your answer should be very brief. 0.36. What is the ratio of the Taxes (in $) in Taxes on goods and services in 2003 to that in 2008?
Provide a short and direct response. 0.55. What is the ratio of the Taxes (in $) of Taxes on income in 2003 to that in 2008?
Offer a very short reply. 0.67. What is the ratio of the Taxes (in $) in Taxes on exports in 2004 to that in 2005?
Offer a very short reply. 1.06. What is the ratio of the Taxes (in $) of Taxes on goods and services in 2004 to that in 2005?
Give a very brief answer. 1.01. What is the ratio of the Taxes (in $) of Taxes on income in 2004 to that in 2005?
Provide a succinct answer. 0.99. What is the ratio of the Taxes (in $) in Taxes on revenue in 2004 to that in 2006?
Provide a short and direct response. 0.91. What is the ratio of the Taxes (in $) in Taxes on exports in 2004 to that in 2006?
Your answer should be very brief. 0.44. What is the ratio of the Taxes (in $) in Taxes on goods and services in 2004 to that in 2006?
Keep it short and to the point. 0.87. What is the ratio of the Taxes (in $) of Taxes on income in 2004 to that in 2006?
Provide a short and direct response. 0.93. What is the ratio of the Taxes (in $) in Taxes on revenue in 2004 to that in 2007?
Offer a very short reply. 0.78. What is the ratio of the Taxes (in $) in Taxes on exports in 2004 to that in 2007?
Ensure brevity in your answer.  0.42. What is the ratio of the Taxes (in $) in Taxes on goods and services in 2004 to that in 2007?
Offer a very short reply. 0.71. What is the ratio of the Taxes (in $) in Taxes on income in 2004 to that in 2007?
Your answer should be compact. 0.83. What is the ratio of the Taxes (in $) of Taxes on revenue in 2004 to that in 2008?
Your response must be concise. 0.68. What is the ratio of the Taxes (in $) of Taxes on exports in 2004 to that in 2008?
Offer a terse response. 0.3. What is the ratio of the Taxes (in $) of Taxes on goods and services in 2004 to that in 2008?
Give a very brief answer. 0.62. What is the ratio of the Taxes (in $) in Taxes on income in 2004 to that in 2008?
Ensure brevity in your answer.  0.73. What is the ratio of the Taxes (in $) in Taxes on revenue in 2005 to that in 2006?
Your response must be concise. 0.92. What is the ratio of the Taxes (in $) of Taxes on exports in 2005 to that in 2006?
Keep it short and to the point. 0.41. What is the ratio of the Taxes (in $) in Taxes on goods and services in 2005 to that in 2006?
Your response must be concise. 0.86. What is the ratio of the Taxes (in $) in Taxes on income in 2005 to that in 2006?
Provide a short and direct response. 0.93. What is the ratio of the Taxes (in $) in Taxes on revenue in 2005 to that in 2007?
Provide a short and direct response. 0.78. What is the ratio of the Taxes (in $) in Taxes on exports in 2005 to that in 2007?
Offer a very short reply. 0.39. What is the ratio of the Taxes (in $) in Taxes on goods and services in 2005 to that in 2007?
Your answer should be very brief. 0.7. What is the ratio of the Taxes (in $) in Taxes on income in 2005 to that in 2007?
Give a very brief answer. 0.83. What is the ratio of the Taxes (in $) of Taxes on revenue in 2005 to that in 2008?
Your response must be concise. 0.68. What is the ratio of the Taxes (in $) in Taxes on exports in 2005 to that in 2008?
Provide a short and direct response. 0.28. What is the ratio of the Taxes (in $) of Taxes on goods and services in 2005 to that in 2008?
Make the answer very short. 0.62. What is the ratio of the Taxes (in $) in Taxes on income in 2005 to that in 2008?
Provide a succinct answer. 0.74. What is the ratio of the Taxes (in $) in Taxes on revenue in 2006 to that in 2007?
Offer a terse response. 0.85. What is the ratio of the Taxes (in $) of Taxes on exports in 2006 to that in 2007?
Your answer should be compact. 0.95. What is the ratio of the Taxes (in $) in Taxes on goods and services in 2006 to that in 2007?
Offer a very short reply. 0.82. What is the ratio of the Taxes (in $) of Taxes on income in 2006 to that in 2007?
Offer a very short reply. 0.89. What is the ratio of the Taxes (in $) of Taxes on revenue in 2006 to that in 2008?
Make the answer very short. 0.74. What is the ratio of the Taxes (in $) in Taxes on exports in 2006 to that in 2008?
Your response must be concise. 0.68. What is the ratio of the Taxes (in $) of Taxes on goods and services in 2006 to that in 2008?
Your response must be concise. 0.72. What is the ratio of the Taxes (in $) in Taxes on income in 2006 to that in 2008?
Your response must be concise. 0.79. What is the ratio of the Taxes (in $) of Taxes on revenue in 2007 to that in 2008?
Give a very brief answer. 0.87. What is the ratio of the Taxes (in $) in Taxes on exports in 2007 to that in 2008?
Make the answer very short. 0.72. What is the ratio of the Taxes (in $) of Taxes on goods and services in 2007 to that in 2008?
Your response must be concise. 0.88. What is the ratio of the Taxes (in $) of Taxes on income in 2007 to that in 2008?
Your answer should be compact. 0.89. What is the difference between the highest and the second highest Taxes (in $) in Taxes on revenue?
Your answer should be very brief. 6.57e+1. What is the difference between the highest and the second highest Taxes (in $) of Taxes on exports?
Offer a terse response. 9.29e+08. What is the difference between the highest and the second highest Taxes (in $) in Taxes on goods and services?
Your response must be concise. 3.05e+1. What is the difference between the highest and the second highest Taxes (in $) of Taxes on income?
Keep it short and to the point. 1.20e+1. What is the difference between the highest and the lowest Taxes (in $) of Taxes on revenue?
Provide a succinct answer. 1.91e+11. What is the difference between the highest and the lowest Taxes (in $) in Taxes on exports?
Provide a short and direct response. 2.35e+09. What is the difference between the highest and the lowest Taxes (in $) of Taxes on goods and services?
Your answer should be very brief. 1.12e+11. What is the difference between the highest and the lowest Taxes (in $) of Taxes on income?
Keep it short and to the point. 3.54e+1. 